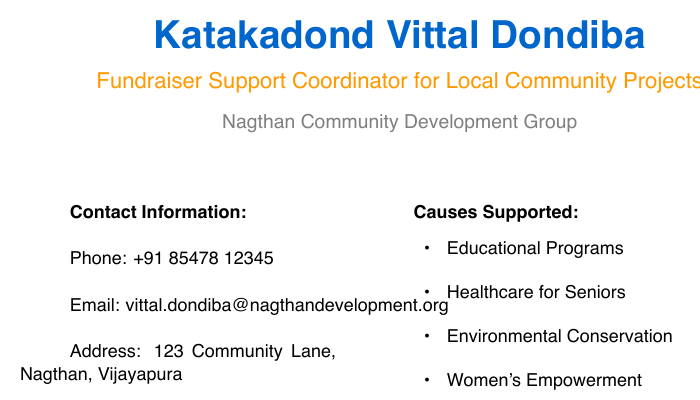What is the name of the coordinator? The document states the name of the coordinator at the top, which is Katakadond Vittal Dondiba.
Answer: Katakadond Vittal Dondiba What is the email address for contact? The email address is provided under the contact information section in the document.
Answer: vittal.dondiba@nagthandevelopment.org What phone number can be used to reach the coordinator? The phone number is mentioned explicitly in the contact information section of the document.
Answer: +91 85478 12345 What causes are supported by the organization? The document lists various causes under the "Causes Supported" section that viewers can read.
Answer: Educational Programs, Healthcare for Seniors, Environmental Conservation, Women's Empowerment Where can donations be made online? The document provides a website link where donations can be made online as part of the donation instructions.
Answer: www.nagthandevelopment.org/donate What type of payment methods are mentioned for donations? The document specifies different payment methods in the "How to Donate" section, requiring reasoning across that information.
Answer: Online, Bank Transfer, Cheque What is the address of the Nagthan Community Development Group? The address is located in the contact information section of the document.
Answer: 123 Community Lane, Nagthan, Vijayapura What does the role of the coordinator involve? The document indicates the coordinator's role as Fundraiser Support Coordinator for local community projects, suggesting their responsibilities.
Answer: Fundraiser Support Coordinator for Local Community Projects 